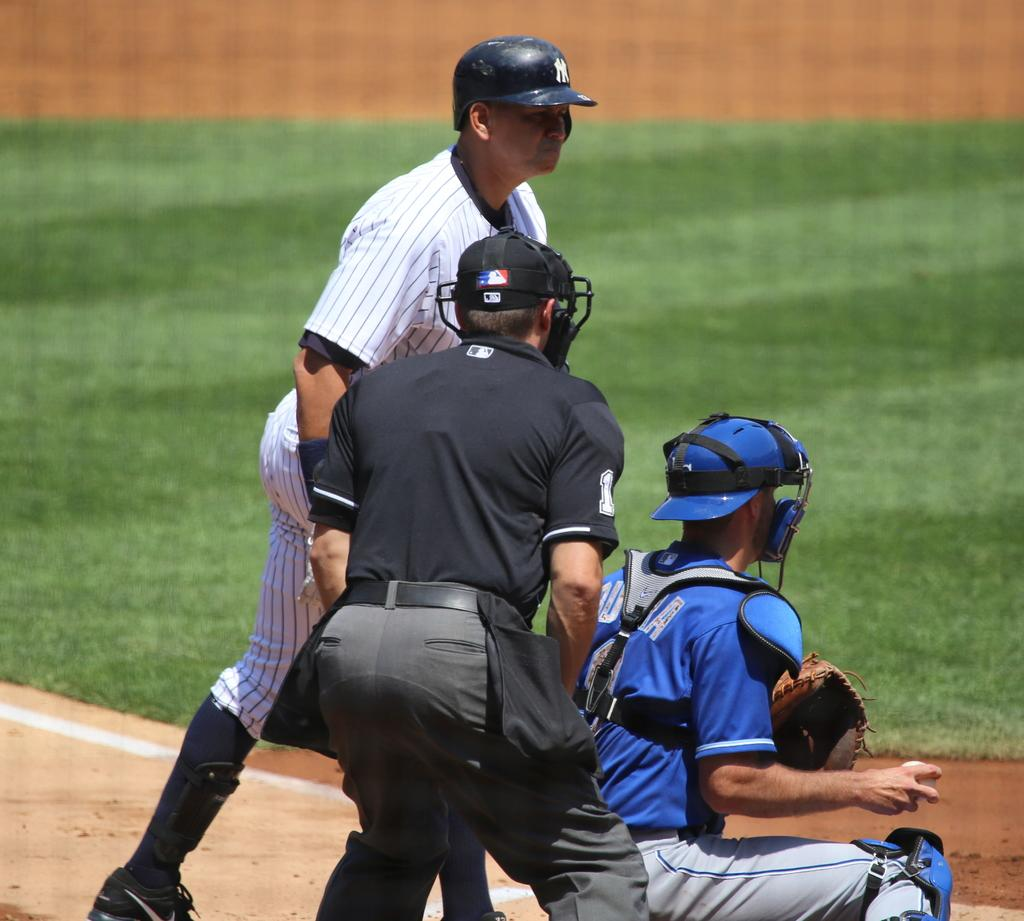How many people are in the image? There are three people in the image. What are the people wearing on their heads? The people are wearing helmets. What is the man holding in his hand? One man is holding a ball in his hand. What can be seen in the background of the image? There is ground visible in the background of the image. What type of farm animals can be seen in the image? There are no farm animals present in the image. Is there a house visible in the image? The provided facts do not mention a house, so we cannot determine if one is visible in the image. 